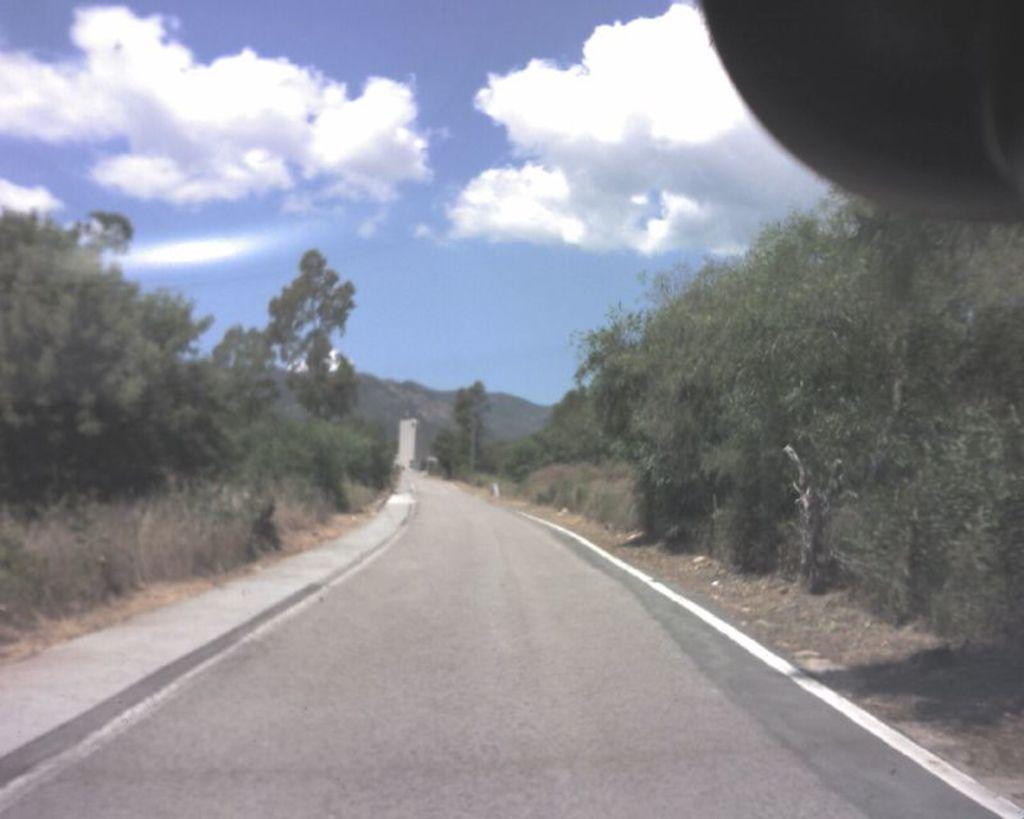Can you describe this image briefly? There is a road. On the sides of the road there are trees. In the background there is sky with clouds. 